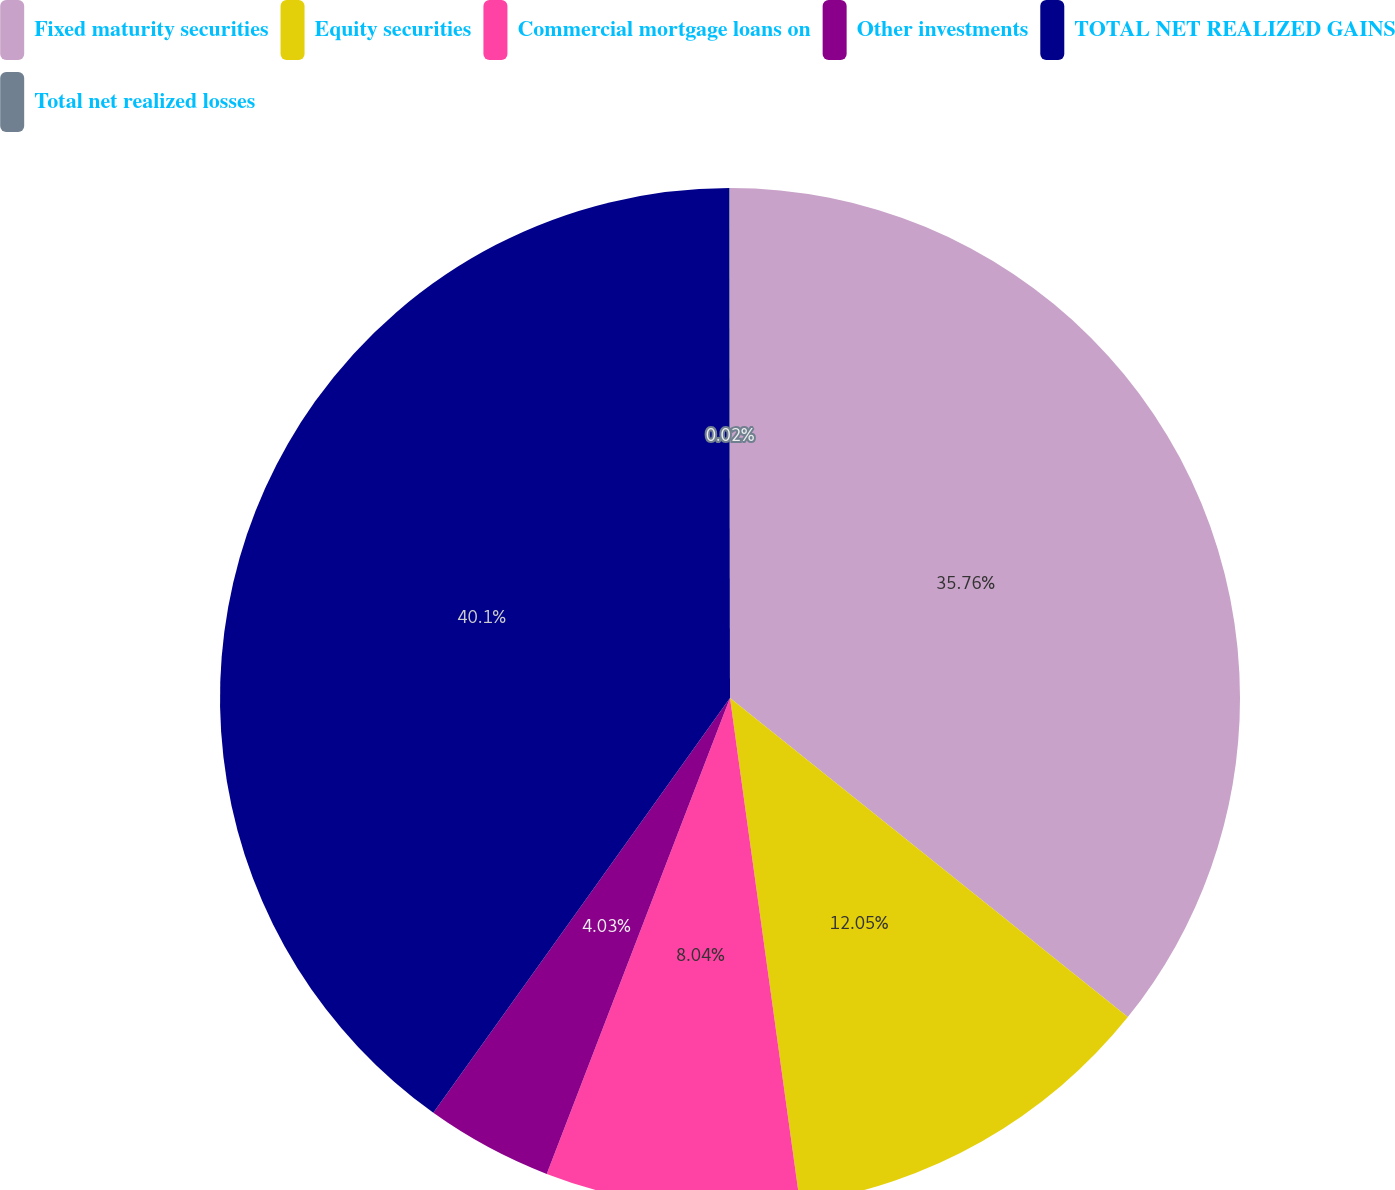Convert chart. <chart><loc_0><loc_0><loc_500><loc_500><pie_chart><fcel>Fixed maturity securities<fcel>Equity securities<fcel>Commercial mortgage loans on<fcel>Other investments<fcel>TOTAL NET REALIZED GAINS<fcel>Total net realized losses<nl><fcel>35.76%<fcel>12.05%<fcel>8.04%<fcel>4.03%<fcel>40.1%<fcel>0.02%<nl></chart> 